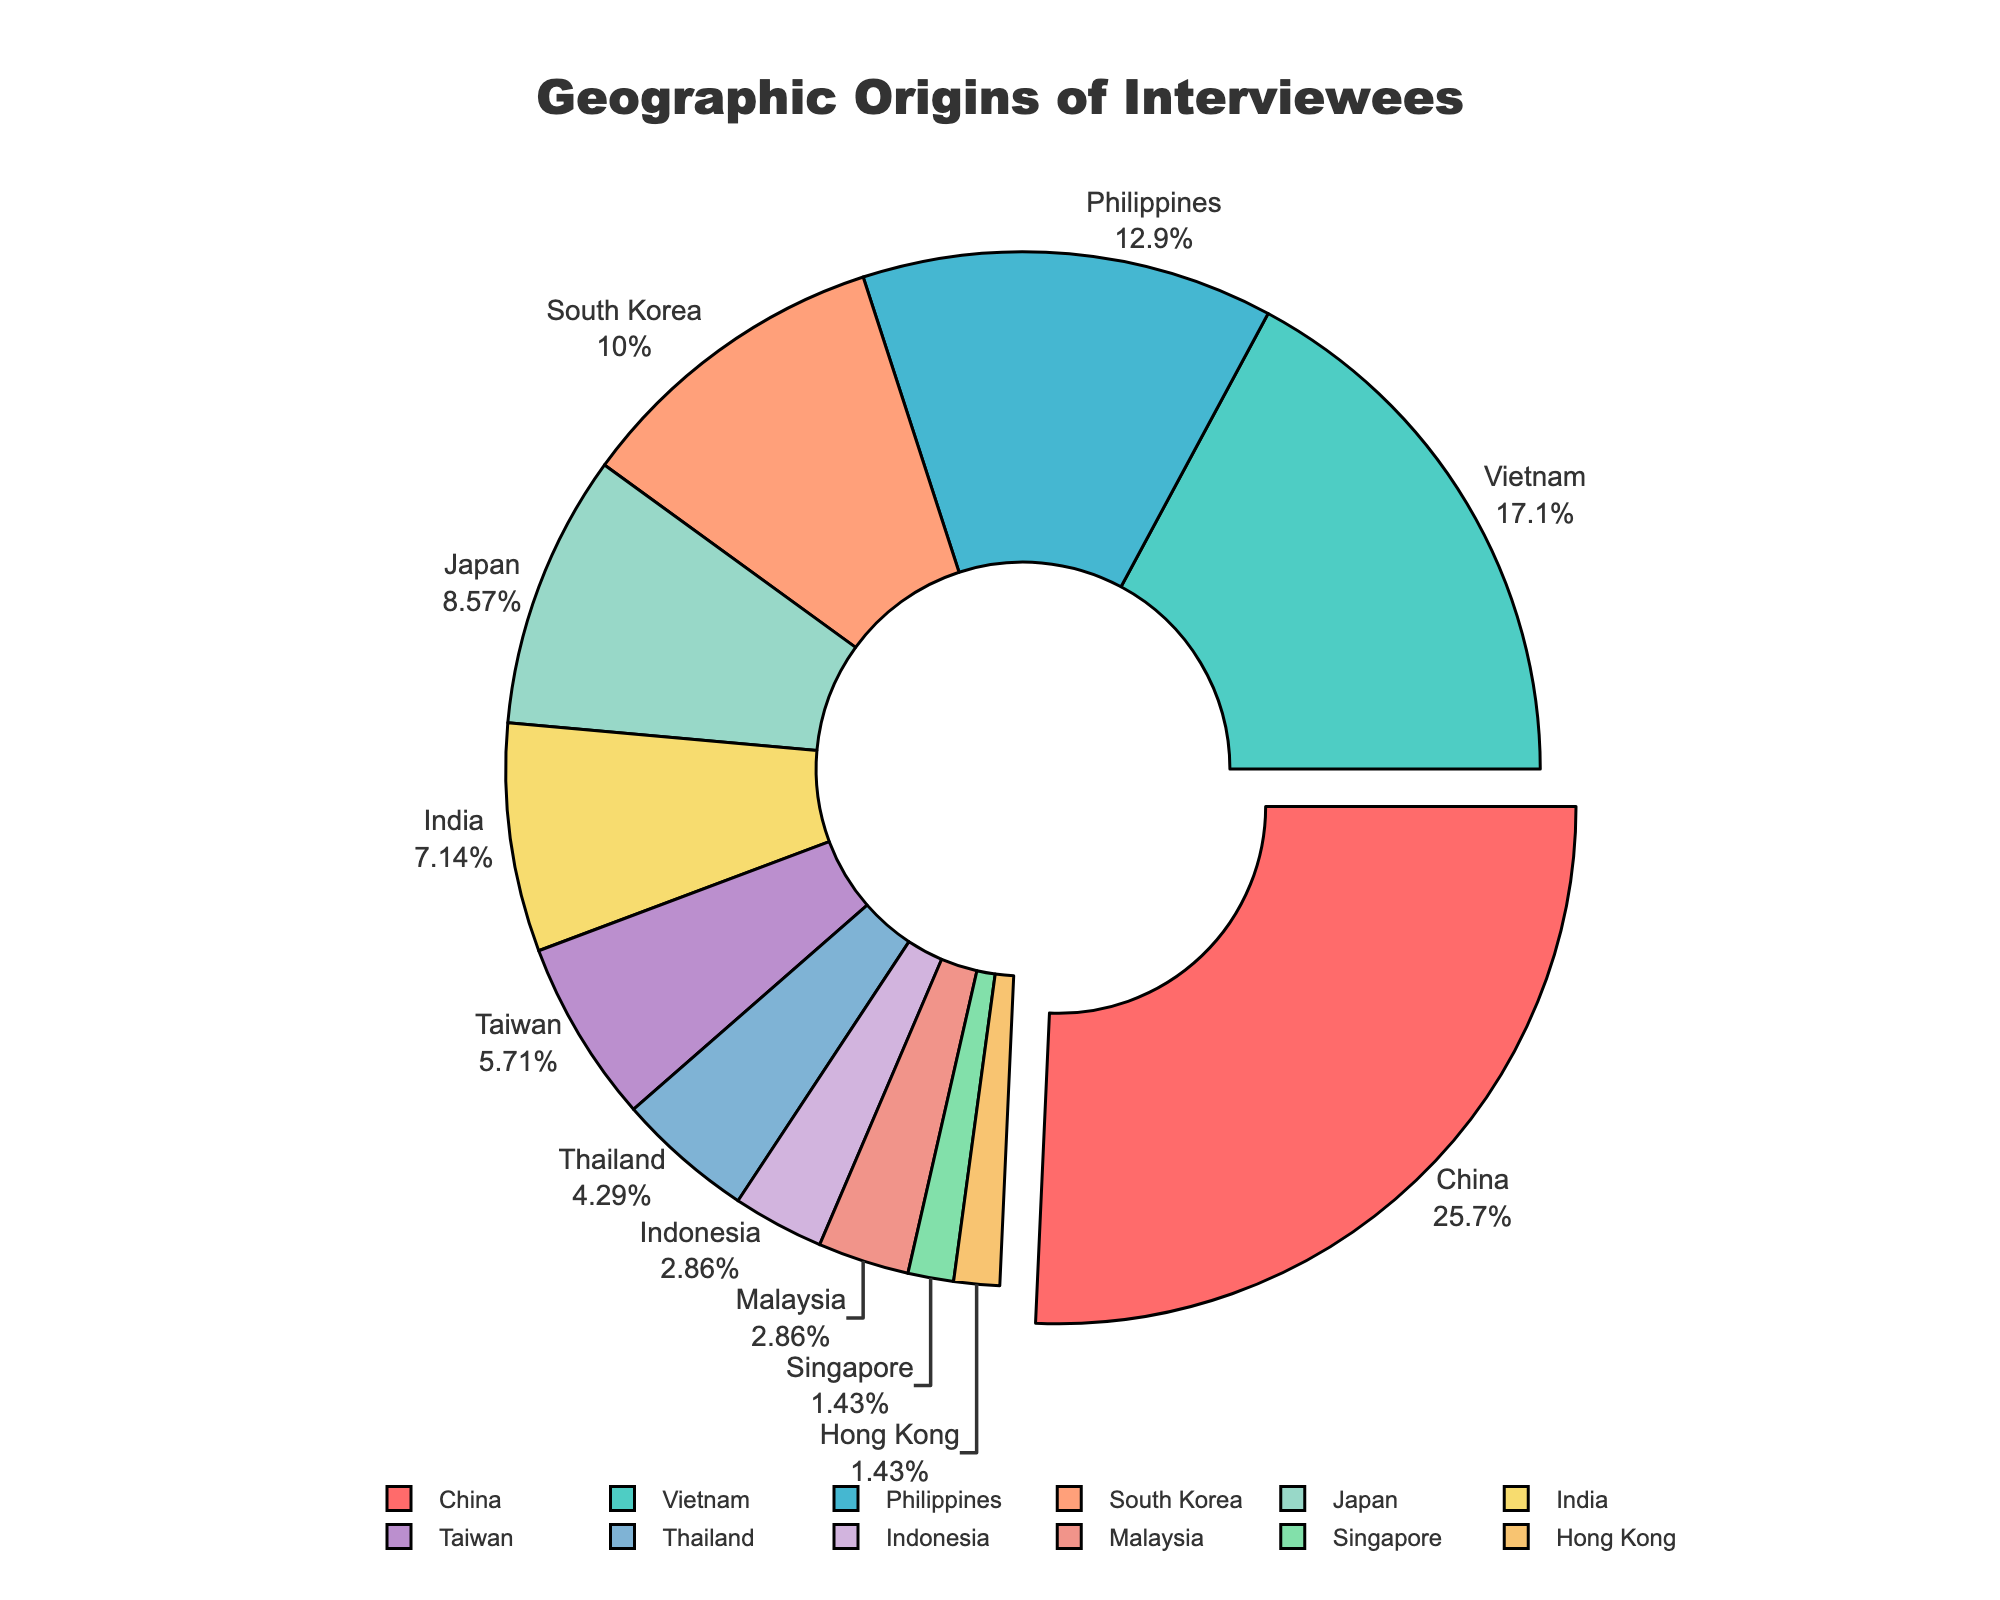What's the most represented region among the interviewees? We can look at the segment of the pie chart that stands out the most. The region with the largest percentage slice (pulled out slightly) is China.
Answer: China What's the difference in the number of interviewees between the highest and lowest represented regions? The highest represented region is China with 18 interviewees, and the lowest represented regions are Singapore and Hong Kong with 1 interviewee each. Therefore, the difference is 18 - 1 = 17.
Answer: 17 What is the combined percentage of interviewees from Vietnam and the Philippines? Vietnam has 12 interviewees and the Philippines has 9. The total number of interviewees is 70. The combined percentage is ((12 + 9) / 70) * 100 = 30%.
Answer: 30% How does the number of interviewees from Japan compare to those from South Korea? Japan has 6 interviewees and South Korea has 7 interviewees. Thus, South Korea has 1 more interviewee than Japan.
Answer: South Korea has 1 more Which regions have less than 5 interviewees each? To find this, we need to identify the regions with fewer than 5 interviewees from the chart. Regions with less than 5 interviewees are Taiwan, Thailand, Indonesia, Malaysia, Singapore, and Hong Kong.
Answer: Taiwan, Thailand, Indonesia, Malaysia, Singapore, Hong Kong What visual elements highlight the region with the most interviewees? The slice for China is enlarged (pulled out slightly) and has a prominent color.
Answer: Enlarged slice and color What is the average number of interviewees across all regions? The total number of interviewees is 70, and there are 12 regions. The average is 70 / 12 = approximately 5.83.
Answer: Approximately 5.83 Which regions have an equal number of interviewees, and what is that number? Malaysia and Indonesia both have 2 interviewees each.
Answer: Malaysia and Indonesia, 2 What fraction of the total interviewees comes from India and Japan combined? India has 5 interviewees and Japan has 6. Combined, they have 11. The fraction is 11 / 70 = 11/70.
Answer: 11/70 What is the percentage difference between the number of interviewees from the Philippines and India? The Philippines has 9 interviewees and India has 5. The difference is 9 - 5 = 4. The percentage difference is (4 / 70) * 100 ≈ 5.71%.
Answer: 5.71% 